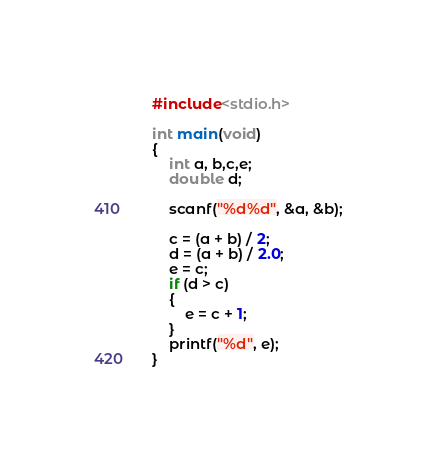Convert code to text. <code><loc_0><loc_0><loc_500><loc_500><_C_>#include<stdio.h>

int main(void)
{
	int a, b,c,e;
	double d;
	
	scanf("%d%d", &a, &b);
	
	c = (a + b) / 2;
	d = (a + b) / 2.0;
	e = c;
	if (d > c)
	{
		e = c + 1;
	}
	printf("%d", e);
}</code> 